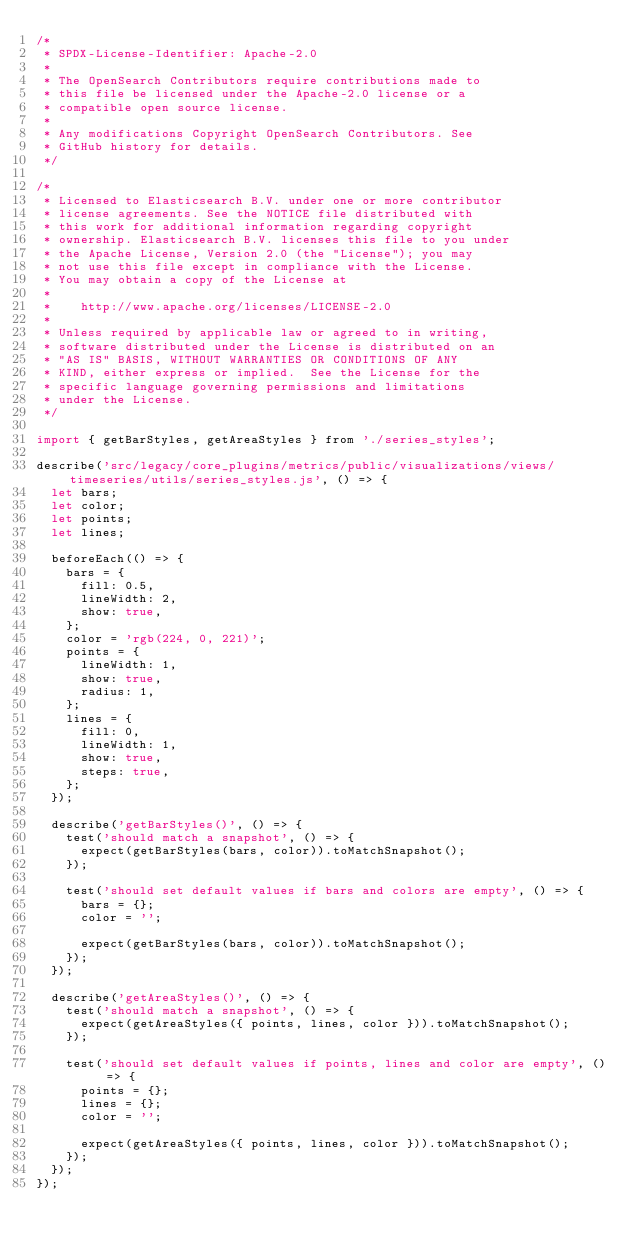<code> <loc_0><loc_0><loc_500><loc_500><_JavaScript_>/*
 * SPDX-License-Identifier: Apache-2.0
 *
 * The OpenSearch Contributors require contributions made to
 * this file be licensed under the Apache-2.0 license or a
 * compatible open source license.
 *
 * Any modifications Copyright OpenSearch Contributors. See
 * GitHub history for details.
 */

/*
 * Licensed to Elasticsearch B.V. under one or more contributor
 * license agreements. See the NOTICE file distributed with
 * this work for additional information regarding copyright
 * ownership. Elasticsearch B.V. licenses this file to you under
 * the Apache License, Version 2.0 (the "License"); you may
 * not use this file except in compliance with the License.
 * You may obtain a copy of the License at
 *
 *    http://www.apache.org/licenses/LICENSE-2.0
 *
 * Unless required by applicable law or agreed to in writing,
 * software distributed under the License is distributed on an
 * "AS IS" BASIS, WITHOUT WARRANTIES OR CONDITIONS OF ANY
 * KIND, either express or implied.  See the License for the
 * specific language governing permissions and limitations
 * under the License.
 */

import { getBarStyles, getAreaStyles } from './series_styles';

describe('src/legacy/core_plugins/metrics/public/visualizations/views/timeseries/utils/series_styles.js', () => {
  let bars;
  let color;
  let points;
  let lines;

  beforeEach(() => {
    bars = {
      fill: 0.5,
      lineWidth: 2,
      show: true,
    };
    color = 'rgb(224, 0, 221)';
    points = {
      lineWidth: 1,
      show: true,
      radius: 1,
    };
    lines = {
      fill: 0,
      lineWidth: 1,
      show: true,
      steps: true,
    };
  });

  describe('getBarStyles()', () => {
    test('should match a snapshot', () => {
      expect(getBarStyles(bars, color)).toMatchSnapshot();
    });

    test('should set default values if bars and colors are empty', () => {
      bars = {};
      color = '';

      expect(getBarStyles(bars, color)).toMatchSnapshot();
    });
  });

  describe('getAreaStyles()', () => {
    test('should match a snapshot', () => {
      expect(getAreaStyles({ points, lines, color })).toMatchSnapshot();
    });

    test('should set default values if points, lines and color are empty', () => {
      points = {};
      lines = {};
      color = '';

      expect(getAreaStyles({ points, lines, color })).toMatchSnapshot();
    });
  });
});
</code> 